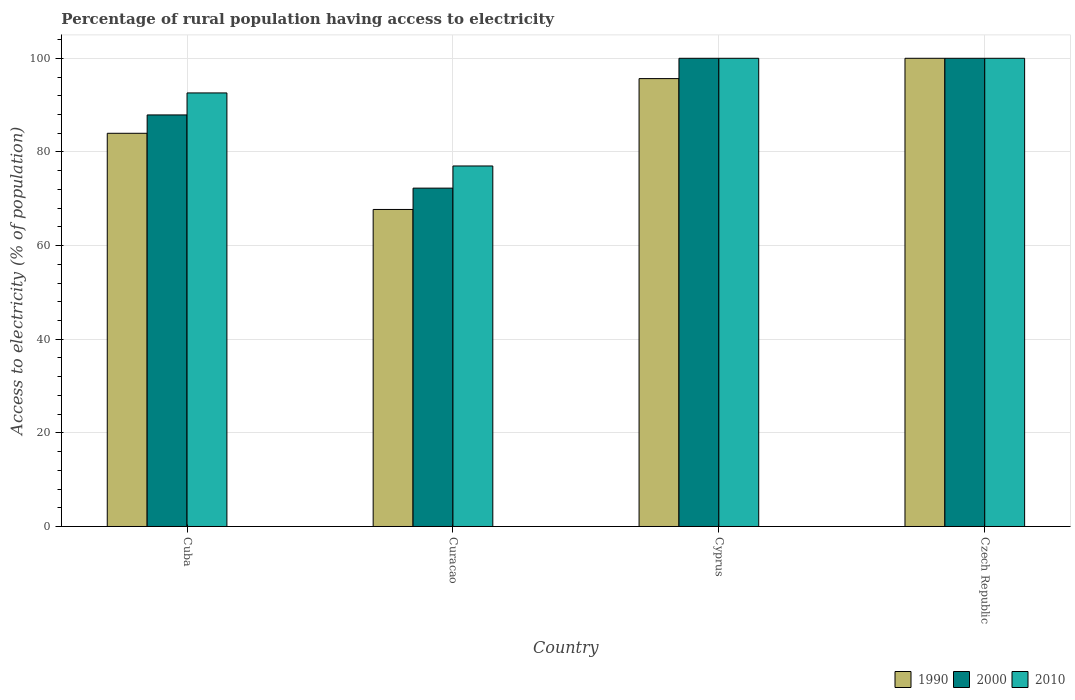How many different coloured bars are there?
Your answer should be very brief. 3. How many groups of bars are there?
Give a very brief answer. 4. Are the number of bars on each tick of the X-axis equal?
Ensure brevity in your answer.  Yes. What is the label of the 3rd group of bars from the left?
Provide a short and direct response. Cyprus. In which country was the percentage of rural population having access to electricity in 2010 maximum?
Your answer should be compact. Cyprus. In which country was the percentage of rural population having access to electricity in 2010 minimum?
Provide a short and direct response. Curacao. What is the total percentage of rural population having access to electricity in 2000 in the graph?
Ensure brevity in your answer.  360.17. What is the difference between the percentage of rural population having access to electricity in 1990 in Cyprus and the percentage of rural population having access to electricity in 2000 in Czech Republic?
Your answer should be compact. -4.34. What is the average percentage of rural population having access to electricity in 2010 per country?
Your answer should be very brief. 92.4. What is the difference between the percentage of rural population having access to electricity of/in 1990 and percentage of rural population having access to electricity of/in 2000 in Cuba?
Your answer should be very brief. -3.92. What is the ratio of the percentage of rural population having access to electricity in 2010 in Curacao to that in Cyprus?
Your response must be concise. 0.77. Is the percentage of rural population having access to electricity in 2010 in Cuba less than that in Curacao?
Provide a short and direct response. No. Is the difference between the percentage of rural population having access to electricity in 1990 in Cyprus and Czech Republic greater than the difference between the percentage of rural population having access to electricity in 2000 in Cyprus and Czech Republic?
Offer a very short reply. No. What is the difference between the highest and the second highest percentage of rural population having access to electricity in 1990?
Your answer should be compact. -16.02. What is the difference between the highest and the lowest percentage of rural population having access to electricity in 2000?
Give a very brief answer. 27.73. In how many countries, is the percentage of rural population having access to electricity in 2010 greater than the average percentage of rural population having access to electricity in 2010 taken over all countries?
Offer a very short reply. 3. Is the sum of the percentage of rural population having access to electricity in 1990 in Curacao and Czech Republic greater than the maximum percentage of rural population having access to electricity in 2010 across all countries?
Ensure brevity in your answer.  Yes. What does the 1st bar from the left in Cuba represents?
Your answer should be compact. 1990. How many countries are there in the graph?
Your response must be concise. 4. What is the difference between two consecutive major ticks on the Y-axis?
Offer a very short reply. 20. Does the graph contain any zero values?
Keep it short and to the point. No. Does the graph contain grids?
Offer a very short reply. Yes. What is the title of the graph?
Ensure brevity in your answer.  Percentage of rural population having access to electricity. Does "1984" appear as one of the legend labels in the graph?
Offer a very short reply. No. What is the label or title of the Y-axis?
Your answer should be very brief. Access to electricity (% of population). What is the Access to electricity (% of population) of 1990 in Cuba?
Your answer should be compact. 83.98. What is the Access to electricity (% of population) in 2000 in Cuba?
Your answer should be very brief. 87.9. What is the Access to electricity (% of population) in 2010 in Cuba?
Your answer should be very brief. 92.6. What is the Access to electricity (% of population) of 1990 in Curacao?
Provide a short and direct response. 67.71. What is the Access to electricity (% of population) of 2000 in Curacao?
Offer a terse response. 72.27. What is the Access to electricity (% of population) of 2010 in Curacao?
Your response must be concise. 77. What is the Access to electricity (% of population) of 1990 in Cyprus?
Offer a terse response. 95.66. What is the Access to electricity (% of population) of 2000 in Cyprus?
Give a very brief answer. 100. What is the Access to electricity (% of population) of 2010 in Cyprus?
Give a very brief answer. 100. Across all countries, what is the maximum Access to electricity (% of population) of 1990?
Your answer should be very brief. 100. Across all countries, what is the maximum Access to electricity (% of population) of 2000?
Your answer should be compact. 100. Across all countries, what is the minimum Access to electricity (% of population) of 1990?
Your answer should be compact. 67.71. Across all countries, what is the minimum Access to electricity (% of population) of 2000?
Offer a very short reply. 72.27. What is the total Access to electricity (% of population) in 1990 in the graph?
Give a very brief answer. 347.35. What is the total Access to electricity (% of population) in 2000 in the graph?
Provide a short and direct response. 360.17. What is the total Access to electricity (% of population) in 2010 in the graph?
Keep it short and to the point. 369.6. What is the difference between the Access to electricity (% of population) of 1990 in Cuba and that in Curacao?
Keep it short and to the point. 16.27. What is the difference between the Access to electricity (% of population) of 2000 in Cuba and that in Curacao?
Provide a succinct answer. 15.63. What is the difference between the Access to electricity (% of population) of 2010 in Cuba and that in Curacao?
Provide a succinct answer. 15.6. What is the difference between the Access to electricity (% of population) of 1990 in Cuba and that in Cyprus?
Your response must be concise. -11.68. What is the difference between the Access to electricity (% of population) in 2000 in Cuba and that in Cyprus?
Give a very brief answer. -12.1. What is the difference between the Access to electricity (% of population) in 2010 in Cuba and that in Cyprus?
Keep it short and to the point. -7.4. What is the difference between the Access to electricity (% of population) in 1990 in Cuba and that in Czech Republic?
Ensure brevity in your answer.  -16.02. What is the difference between the Access to electricity (% of population) of 2010 in Cuba and that in Czech Republic?
Provide a short and direct response. -7.4. What is the difference between the Access to electricity (% of population) of 1990 in Curacao and that in Cyprus?
Offer a terse response. -27.95. What is the difference between the Access to electricity (% of population) of 2000 in Curacao and that in Cyprus?
Offer a very short reply. -27.73. What is the difference between the Access to electricity (% of population) of 1990 in Curacao and that in Czech Republic?
Keep it short and to the point. -32.29. What is the difference between the Access to electricity (% of population) in 2000 in Curacao and that in Czech Republic?
Keep it short and to the point. -27.73. What is the difference between the Access to electricity (% of population) in 1990 in Cyprus and that in Czech Republic?
Make the answer very short. -4.34. What is the difference between the Access to electricity (% of population) in 1990 in Cuba and the Access to electricity (% of population) in 2000 in Curacao?
Make the answer very short. 11.71. What is the difference between the Access to electricity (% of population) in 1990 in Cuba and the Access to electricity (% of population) in 2010 in Curacao?
Provide a short and direct response. 6.98. What is the difference between the Access to electricity (% of population) in 2000 in Cuba and the Access to electricity (% of population) in 2010 in Curacao?
Provide a short and direct response. 10.9. What is the difference between the Access to electricity (% of population) in 1990 in Cuba and the Access to electricity (% of population) in 2000 in Cyprus?
Ensure brevity in your answer.  -16.02. What is the difference between the Access to electricity (% of population) of 1990 in Cuba and the Access to electricity (% of population) of 2010 in Cyprus?
Ensure brevity in your answer.  -16.02. What is the difference between the Access to electricity (% of population) of 2000 in Cuba and the Access to electricity (% of population) of 2010 in Cyprus?
Provide a succinct answer. -12.1. What is the difference between the Access to electricity (% of population) of 1990 in Cuba and the Access to electricity (% of population) of 2000 in Czech Republic?
Give a very brief answer. -16.02. What is the difference between the Access to electricity (% of population) of 1990 in Cuba and the Access to electricity (% of population) of 2010 in Czech Republic?
Give a very brief answer. -16.02. What is the difference between the Access to electricity (% of population) of 1990 in Curacao and the Access to electricity (% of population) of 2000 in Cyprus?
Your answer should be compact. -32.29. What is the difference between the Access to electricity (% of population) of 1990 in Curacao and the Access to electricity (% of population) of 2010 in Cyprus?
Ensure brevity in your answer.  -32.29. What is the difference between the Access to electricity (% of population) of 2000 in Curacao and the Access to electricity (% of population) of 2010 in Cyprus?
Offer a terse response. -27.73. What is the difference between the Access to electricity (% of population) in 1990 in Curacao and the Access to electricity (% of population) in 2000 in Czech Republic?
Provide a succinct answer. -32.29. What is the difference between the Access to electricity (% of population) in 1990 in Curacao and the Access to electricity (% of population) in 2010 in Czech Republic?
Ensure brevity in your answer.  -32.29. What is the difference between the Access to electricity (% of population) in 2000 in Curacao and the Access to electricity (% of population) in 2010 in Czech Republic?
Offer a very short reply. -27.73. What is the difference between the Access to electricity (% of population) in 1990 in Cyprus and the Access to electricity (% of population) in 2000 in Czech Republic?
Give a very brief answer. -4.34. What is the difference between the Access to electricity (% of population) of 1990 in Cyprus and the Access to electricity (% of population) of 2010 in Czech Republic?
Offer a very short reply. -4.34. What is the average Access to electricity (% of population) of 1990 per country?
Provide a succinct answer. 86.84. What is the average Access to electricity (% of population) of 2000 per country?
Your answer should be very brief. 90.04. What is the average Access to electricity (% of population) of 2010 per country?
Give a very brief answer. 92.4. What is the difference between the Access to electricity (% of population) in 1990 and Access to electricity (% of population) in 2000 in Cuba?
Provide a succinct answer. -3.92. What is the difference between the Access to electricity (% of population) in 1990 and Access to electricity (% of population) in 2010 in Cuba?
Make the answer very short. -8.62. What is the difference between the Access to electricity (% of population) in 2000 and Access to electricity (% of population) in 2010 in Cuba?
Offer a terse response. -4.7. What is the difference between the Access to electricity (% of population) of 1990 and Access to electricity (% of population) of 2000 in Curacao?
Keep it short and to the point. -4.55. What is the difference between the Access to electricity (% of population) in 1990 and Access to electricity (% of population) in 2010 in Curacao?
Keep it short and to the point. -9.29. What is the difference between the Access to electricity (% of population) of 2000 and Access to electricity (% of population) of 2010 in Curacao?
Provide a short and direct response. -4.74. What is the difference between the Access to electricity (% of population) of 1990 and Access to electricity (% of population) of 2000 in Cyprus?
Give a very brief answer. -4.34. What is the difference between the Access to electricity (% of population) in 1990 and Access to electricity (% of population) in 2010 in Cyprus?
Your answer should be very brief. -4.34. What is the difference between the Access to electricity (% of population) of 2000 and Access to electricity (% of population) of 2010 in Cyprus?
Offer a very short reply. 0. What is the difference between the Access to electricity (% of population) in 1990 and Access to electricity (% of population) in 2000 in Czech Republic?
Offer a terse response. 0. What is the difference between the Access to electricity (% of population) in 2000 and Access to electricity (% of population) in 2010 in Czech Republic?
Ensure brevity in your answer.  0. What is the ratio of the Access to electricity (% of population) of 1990 in Cuba to that in Curacao?
Your response must be concise. 1.24. What is the ratio of the Access to electricity (% of population) in 2000 in Cuba to that in Curacao?
Your answer should be compact. 1.22. What is the ratio of the Access to electricity (% of population) in 2010 in Cuba to that in Curacao?
Keep it short and to the point. 1.2. What is the ratio of the Access to electricity (% of population) in 1990 in Cuba to that in Cyprus?
Provide a succinct answer. 0.88. What is the ratio of the Access to electricity (% of population) of 2000 in Cuba to that in Cyprus?
Give a very brief answer. 0.88. What is the ratio of the Access to electricity (% of population) in 2010 in Cuba to that in Cyprus?
Your answer should be compact. 0.93. What is the ratio of the Access to electricity (% of population) in 1990 in Cuba to that in Czech Republic?
Provide a succinct answer. 0.84. What is the ratio of the Access to electricity (% of population) in 2000 in Cuba to that in Czech Republic?
Offer a terse response. 0.88. What is the ratio of the Access to electricity (% of population) in 2010 in Cuba to that in Czech Republic?
Your response must be concise. 0.93. What is the ratio of the Access to electricity (% of population) in 1990 in Curacao to that in Cyprus?
Your answer should be very brief. 0.71. What is the ratio of the Access to electricity (% of population) in 2000 in Curacao to that in Cyprus?
Offer a very short reply. 0.72. What is the ratio of the Access to electricity (% of population) in 2010 in Curacao to that in Cyprus?
Provide a succinct answer. 0.77. What is the ratio of the Access to electricity (% of population) in 1990 in Curacao to that in Czech Republic?
Make the answer very short. 0.68. What is the ratio of the Access to electricity (% of population) in 2000 in Curacao to that in Czech Republic?
Your answer should be very brief. 0.72. What is the ratio of the Access to electricity (% of population) of 2010 in Curacao to that in Czech Republic?
Ensure brevity in your answer.  0.77. What is the ratio of the Access to electricity (% of population) of 1990 in Cyprus to that in Czech Republic?
Offer a terse response. 0.96. What is the ratio of the Access to electricity (% of population) in 2000 in Cyprus to that in Czech Republic?
Your answer should be very brief. 1. What is the ratio of the Access to electricity (% of population) of 2010 in Cyprus to that in Czech Republic?
Keep it short and to the point. 1. What is the difference between the highest and the second highest Access to electricity (% of population) in 1990?
Offer a very short reply. 4.34. What is the difference between the highest and the second highest Access to electricity (% of population) of 2000?
Make the answer very short. 0. What is the difference between the highest and the lowest Access to electricity (% of population) of 1990?
Offer a terse response. 32.29. What is the difference between the highest and the lowest Access to electricity (% of population) in 2000?
Make the answer very short. 27.73. What is the difference between the highest and the lowest Access to electricity (% of population) of 2010?
Provide a succinct answer. 23. 